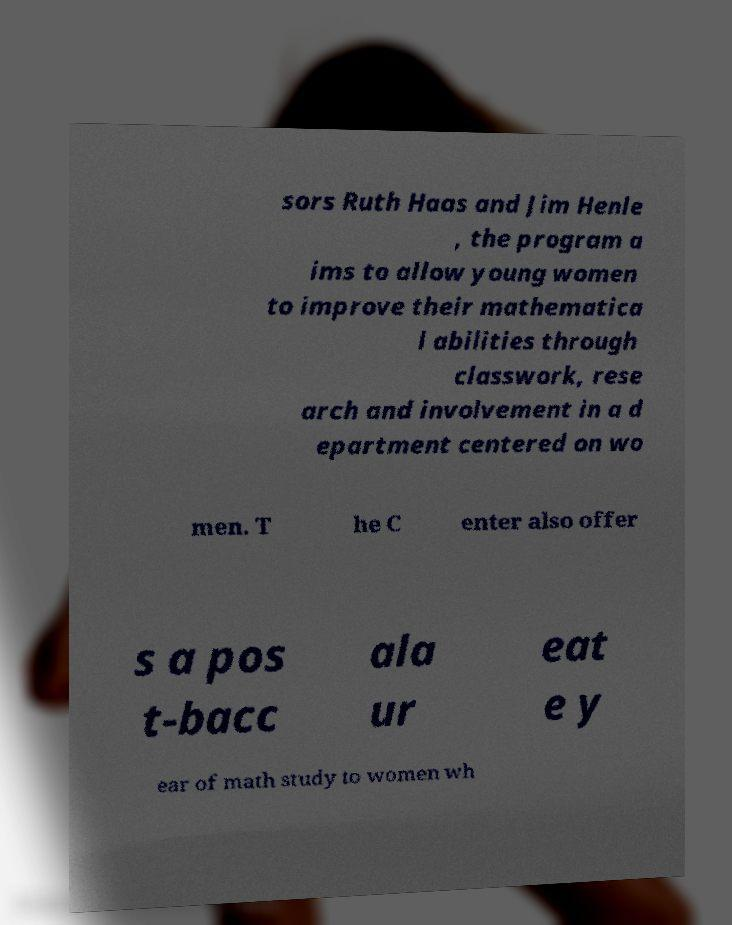I need the written content from this picture converted into text. Can you do that? sors Ruth Haas and Jim Henle , the program a ims to allow young women to improve their mathematica l abilities through classwork, rese arch and involvement in a d epartment centered on wo men. T he C enter also offer s a pos t-bacc ala ur eat e y ear of math study to women wh 